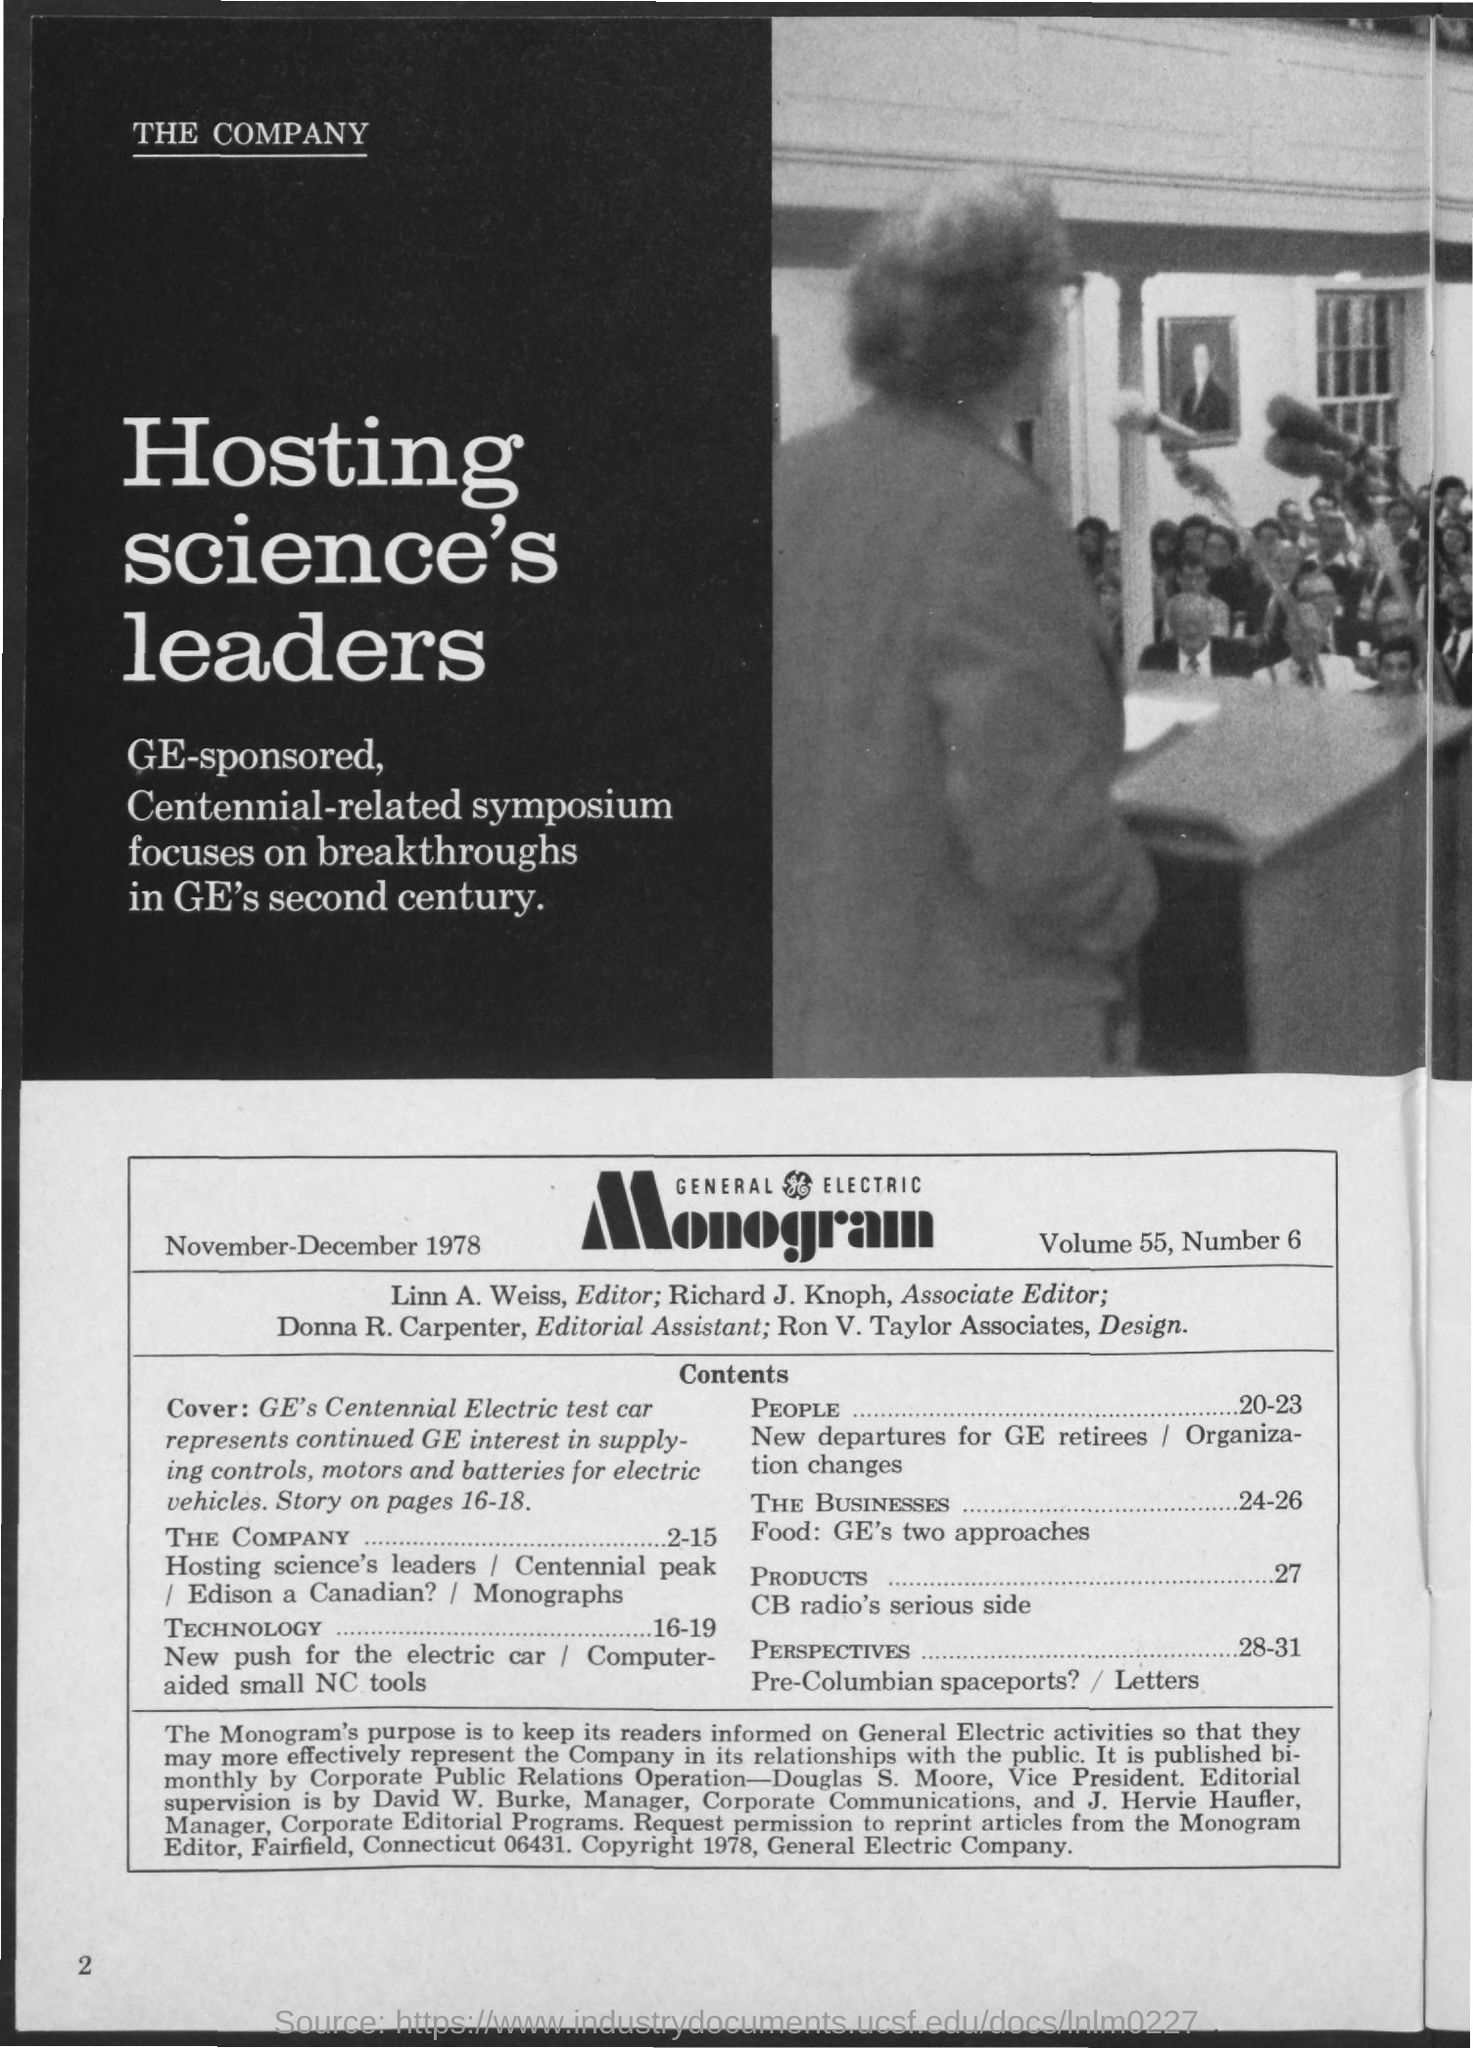Draw attention to some important aspects in this diagram. It is Richard J. Knoph who is the Associate Editor. What is the number, 6...? The date on the document is November-December 1978. The editorial assistant is Donna R. Carpenter. The volume is 55.. 